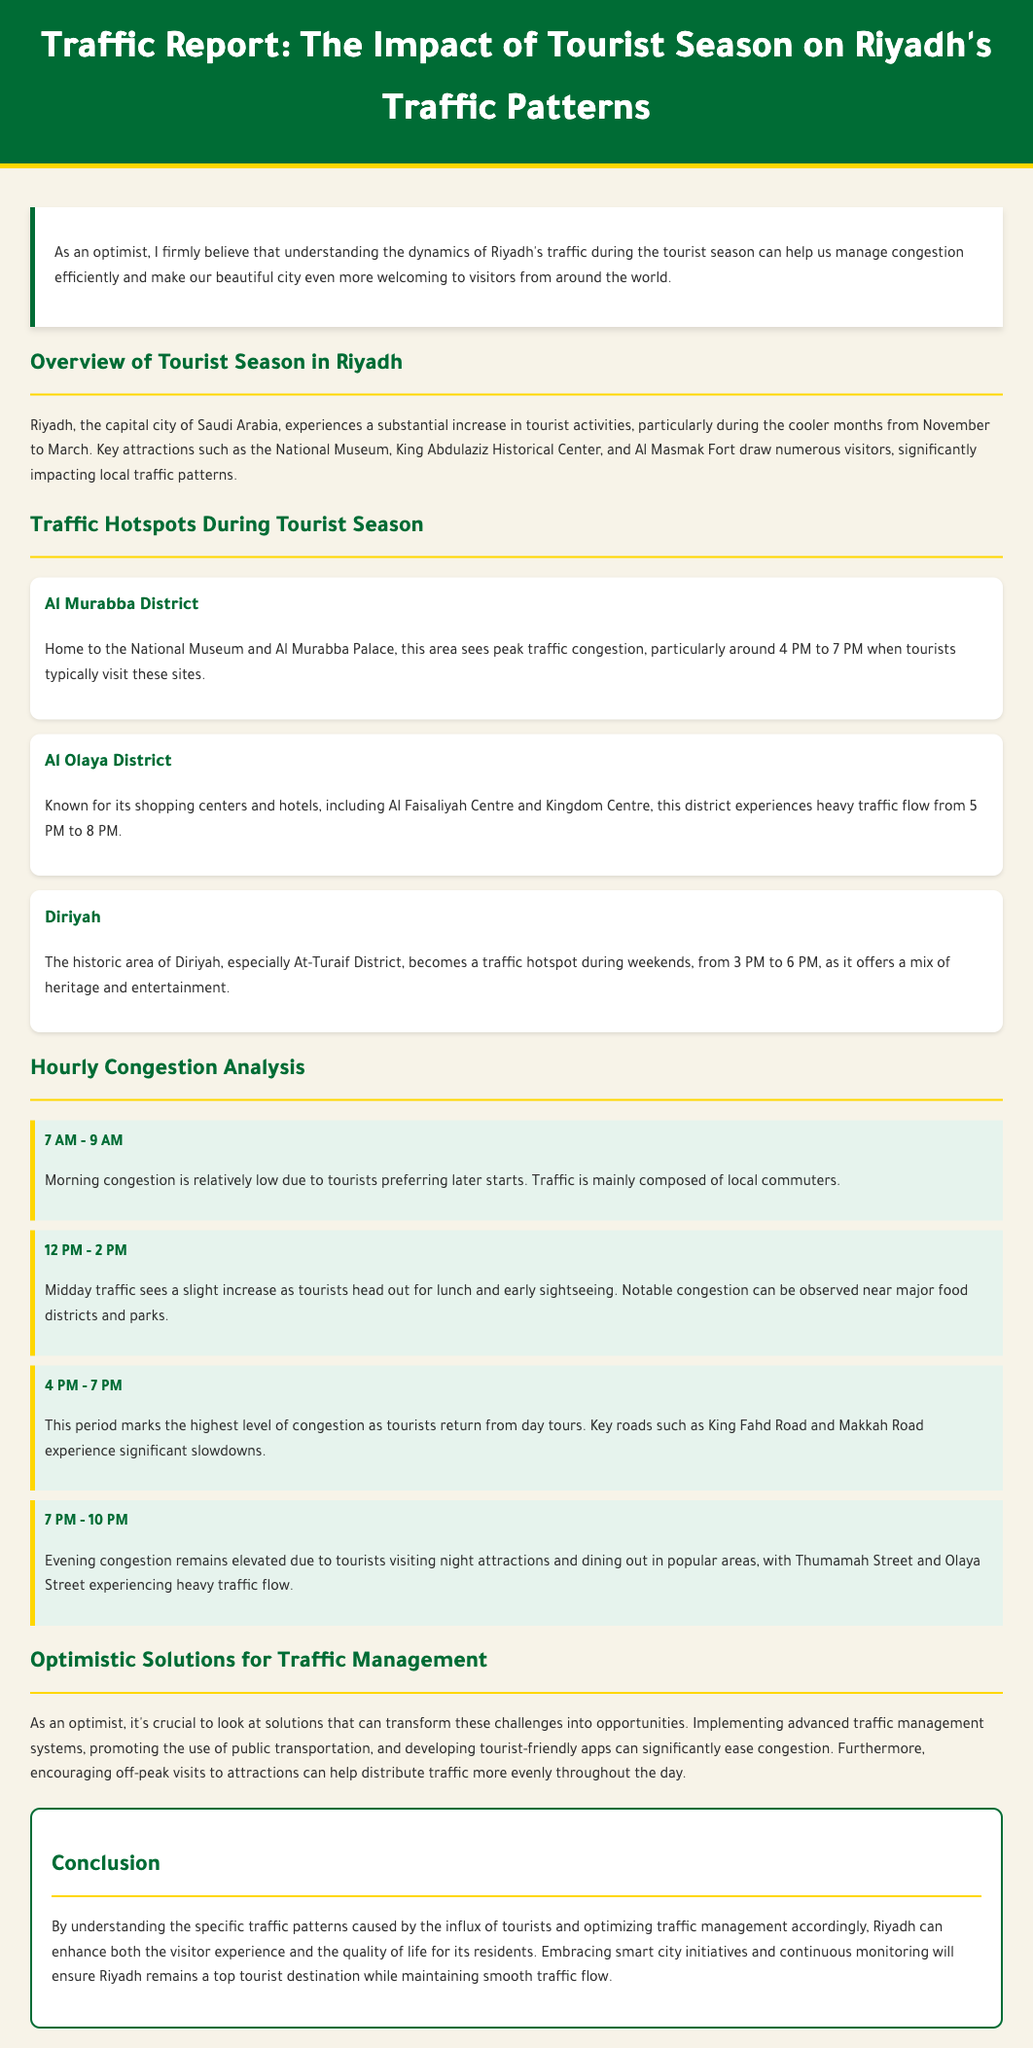What is the peak traffic congestion time in Al Murabba District? The document states that the peak traffic congestion in Al Murabba District occurs around 4 PM to 7 PM.
Answer: 4 PM to 7 PM Which district is known for shopping centers and hotels? The report indicates that Al Olaya District is known for its shopping centers and hotels.
Answer: Al Olaya District When does midday traffic see a slight increase? Midday traffic sees a slight increase during the 12 PM to 2 PM time slot as tourists head out for lunch.
Answer: 12 PM to 2 PM What is a suggested solution for easing congestion? The document suggests promoting the use of public transportation as one solution for easing congestion.
Answer: Public transportation What is the primary reason for evening congestion? The primary reason for evening congestion is tourists visiting night attractions and dining out.
Answer: Night attractions and dining out 